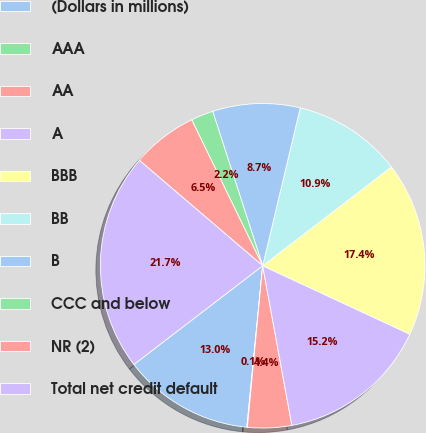Convert chart to OTSL. <chart><loc_0><loc_0><loc_500><loc_500><pie_chart><fcel>(Dollars in millions)<fcel>AAA<fcel>AA<fcel>A<fcel>BBB<fcel>BB<fcel>B<fcel>CCC and below<fcel>NR (2)<fcel>Total net credit default<nl><fcel>13.03%<fcel>0.06%<fcel>4.38%<fcel>15.19%<fcel>17.35%<fcel>10.86%<fcel>8.7%<fcel>2.22%<fcel>6.54%<fcel>21.67%<nl></chart> 